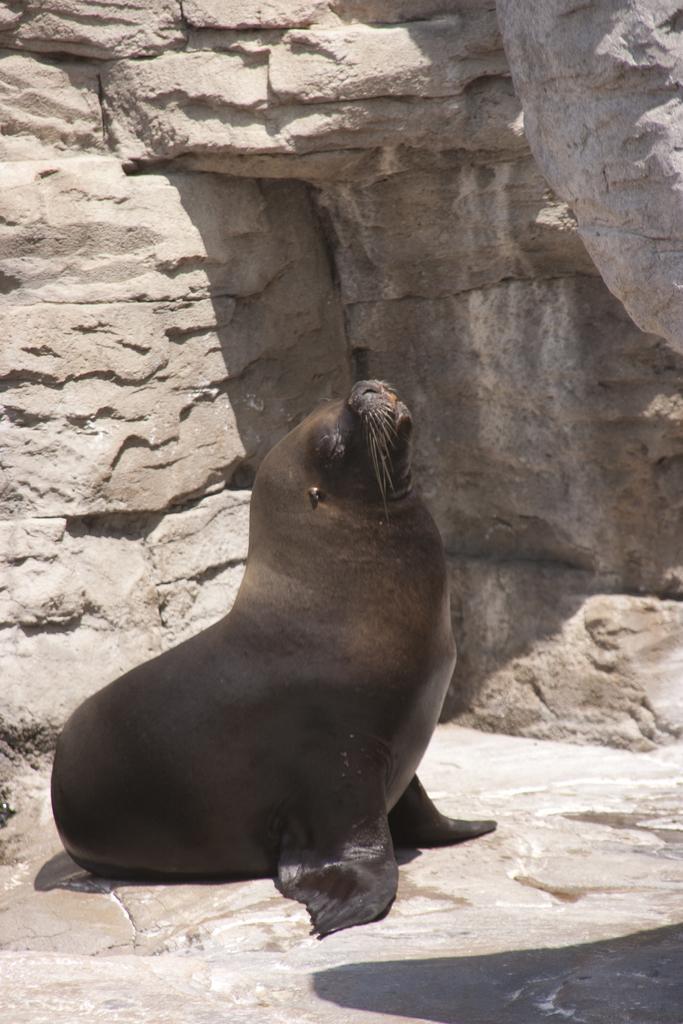Describe this image in one or two sentences. This is the California sea lion. I think this is the rock hill. 